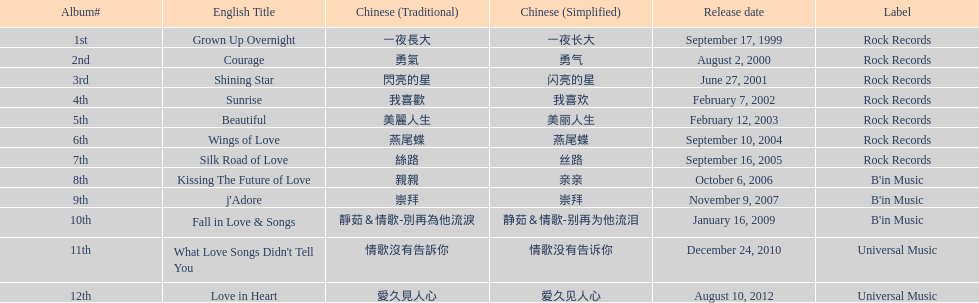Which track is placed first in the table? Grown Up Overnight. 